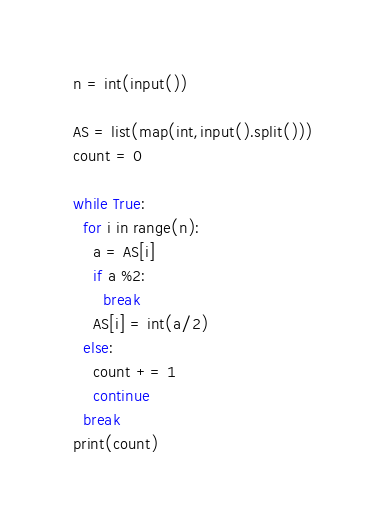Convert code to text. <code><loc_0><loc_0><loc_500><loc_500><_Python_>n = int(input())

AS = list(map(int,input().split()))
count = 0

while True:
  for i in range(n):
    a = AS[i]
    if a %2:
      break
    AS[i] = int(a/2)
  else:
    count += 1
    continue
  break
print(count)</code> 